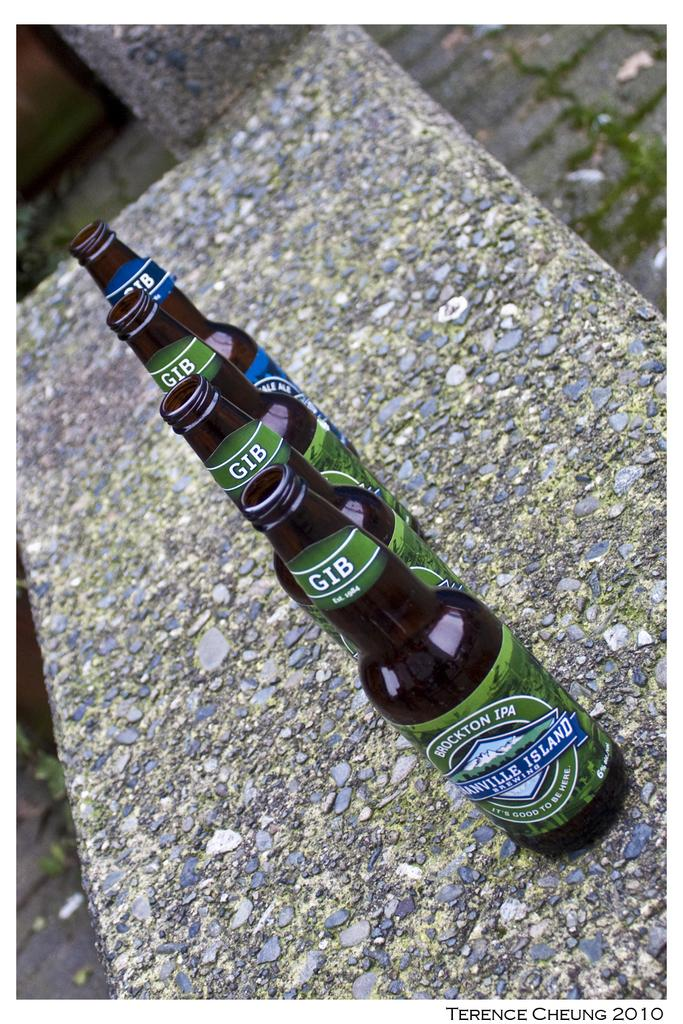Provide a one-sentence caption for the provided image. Four bottles of beer from a company established in 1984 are lined up outdoors. 